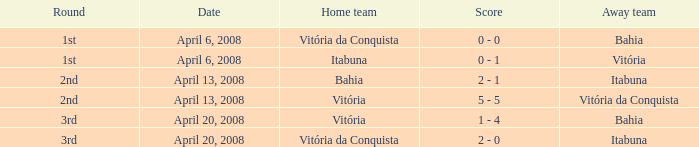Which home side has a score of 5 - 5? Vitória. 